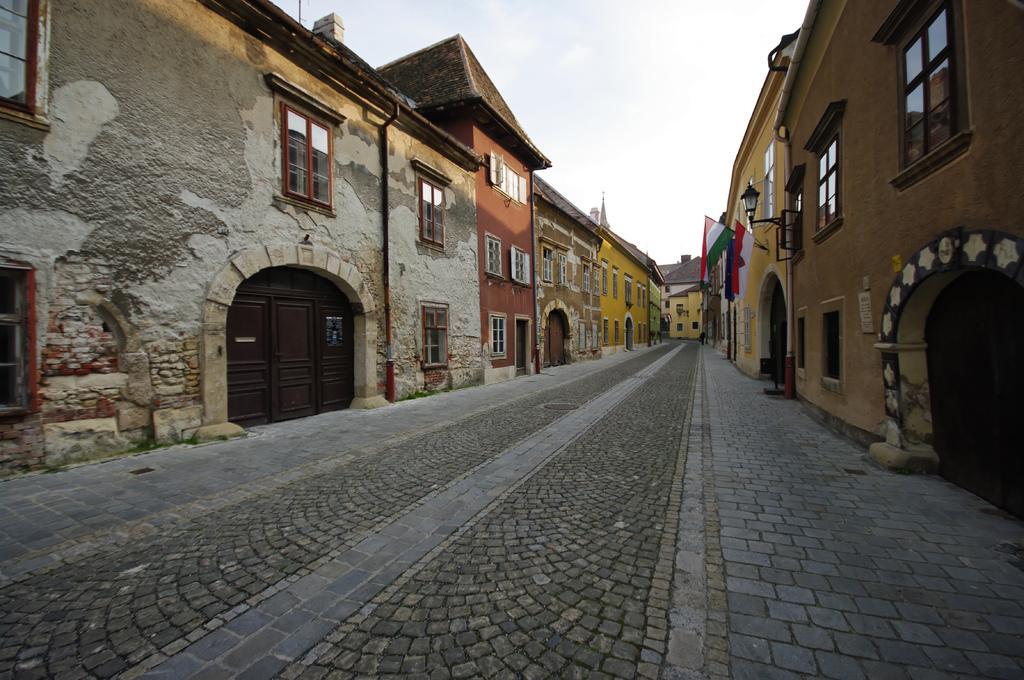In one or two sentences, can you explain what this image depicts? In this picture I can see many buildings. On the right and left side I can see the doors and windows. On the right I can see some flags near to the street light. At the top I can see the sky and clouds. At the bottom there is a road. 